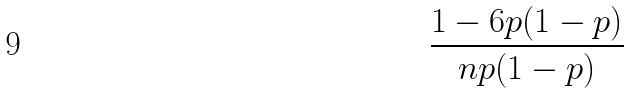Convert formula to latex. <formula><loc_0><loc_0><loc_500><loc_500>\frac { 1 - 6 p ( 1 - p ) } { n p ( 1 - p ) }</formula> 